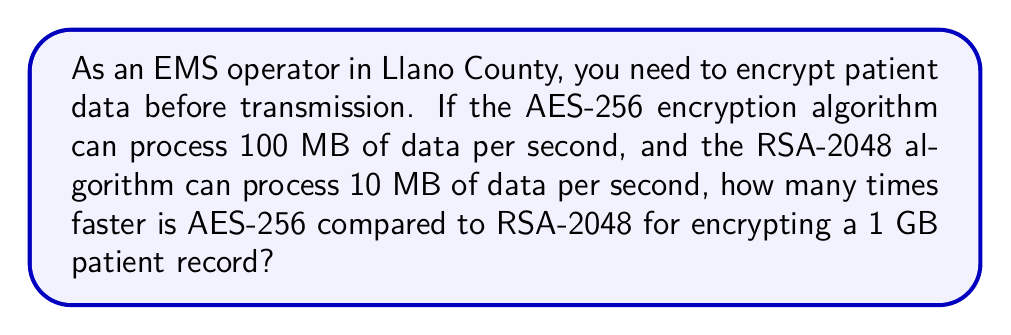Solve this math problem. Let's approach this step-by-step:

1. First, we need to convert 1 GB to MB:
   $1 \text{ GB} = 1000 \text{ MB}$

2. Now, let's calculate the time taken by each algorithm to encrypt 1 GB of data:

   For AES-256:
   $$\text{Time}_{\text{AES}} = \frac{1000 \text{ MB}}{100 \text{ MB/s}} = 10 \text{ seconds}$$

   For RSA-2048:
   $$\text{Time}_{\text{RSA}} = \frac{1000 \text{ MB}}{10 \text{ MB/s}} = 100 \text{ seconds}$$

3. To find how many times faster AES-256 is, we divide the time taken by RSA-2048 by the time taken by AES-256:

   $$\text{Speed Ratio} = \frac{\text{Time}_{\text{RSA}}}{\text{Time}_{\text{AES}}} = \frac{100 \text{ s}}{10 \text{ s}} = 10$$

Therefore, AES-256 is 10 times faster than RSA-2048 for encrypting a 1 GB patient record.
Answer: 10 times faster 